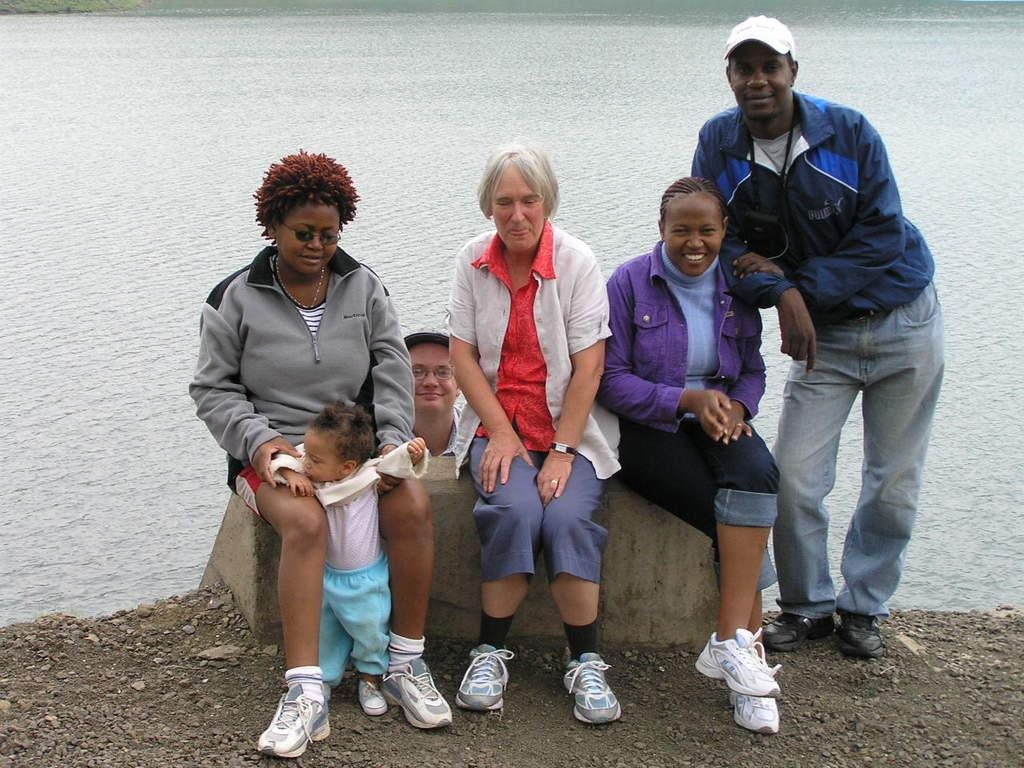How many people are in the image? There are three women in the image. What are the women doing in the image? The women are sitting on a rock. What can be seen in the background of the image? There is water visible in the image. What type of surface is the women sitting on? The women are sitting on a rock. What type of pie is being served in the image? There is no pie present in the image; it features three women sitting on a rock with water visible in the background. 